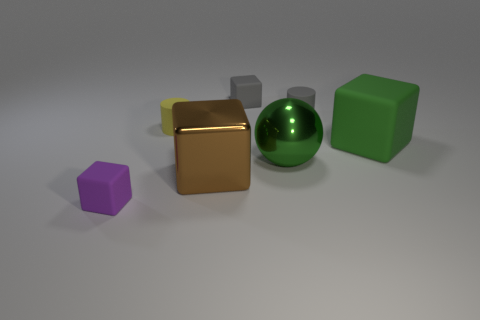Subtract all gray matte cubes. How many cubes are left? 3 Add 2 yellow rubber cylinders. How many objects exist? 9 Subtract all brown cubes. How many cubes are left? 3 Subtract all purple matte things. Subtract all tiny purple matte things. How many objects are left? 5 Add 1 big metallic blocks. How many big metallic blocks are left? 2 Add 2 large green metallic spheres. How many large green metallic spheres exist? 3 Subtract 1 yellow cylinders. How many objects are left? 6 Subtract all cylinders. How many objects are left? 5 Subtract 2 cubes. How many cubes are left? 2 Subtract all green cubes. Subtract all cyan cylinders. How many cubes are left? 3 